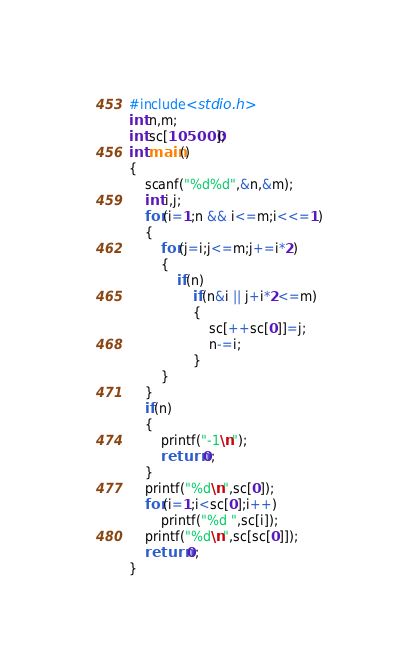Convert code to text. <code><loc_0><loc_0><loc_500><loc_500><_C++_>#include<stdio.h>
int n,m;
int sc[105000];
int main()
{
	scanf("%d%d",&n,&m);
	int i,j;
	for(i=1;n && i<=m;i<<=1)
	{
		for(j=i;j<=m;j+=i*2)
		{
			if(n)
				if(n&i || j+i*2<=m)
				{
					sc[++sc[0]]=j;
					n-=i;
				}
		}
	}
	if(n)
	{
		printf("-1\n");
		return 0;
	}
	printf("%d\n",sc[0]);
	for(i=1;i<sc[0];i++)
		printf("%d ",sc[i]);
	printf("%d\n",sc[sc[0]]);
	return 0;
}
</code> 